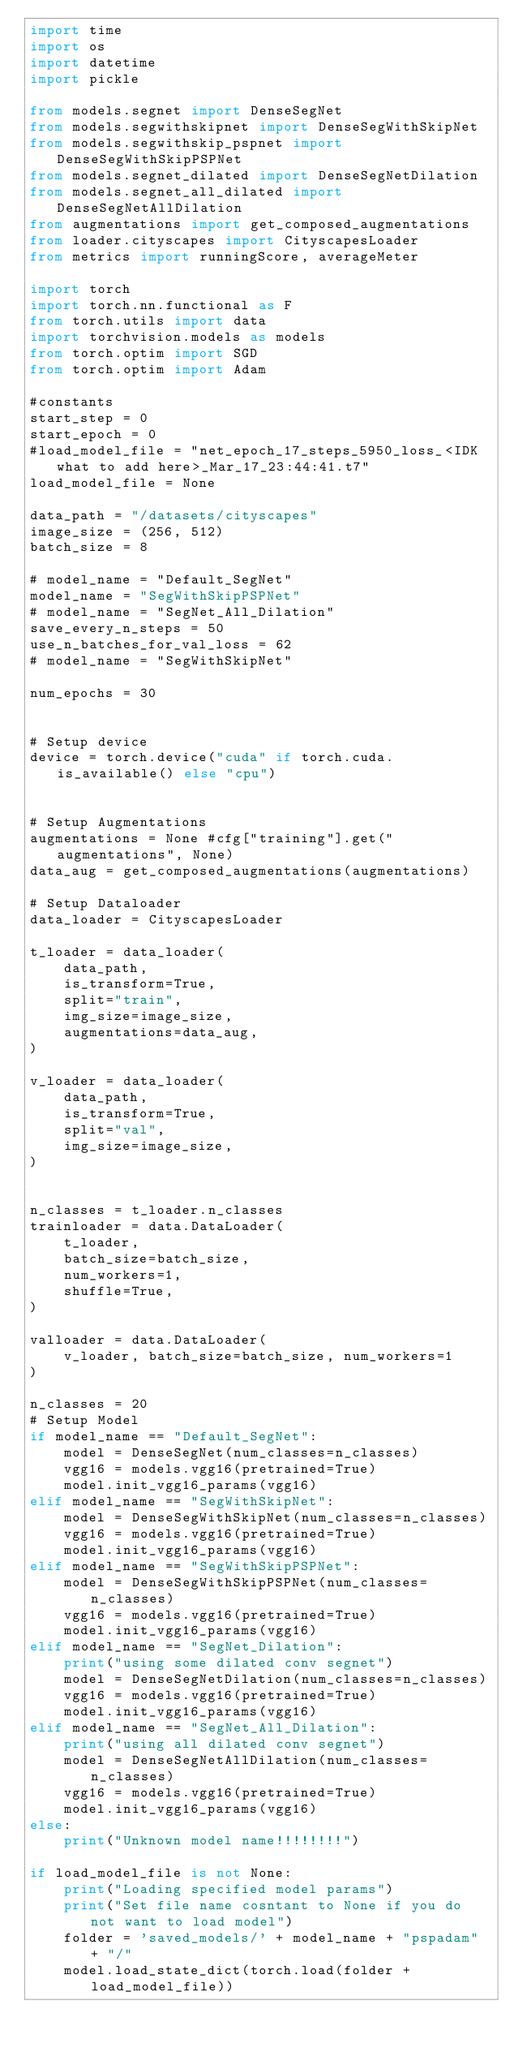Convert code to text. <code><loc_0><loc_0><loc_500><loc_500><_Python_>import time
import os
import datetime
import pickle

from models.segnet import DenseSegNet
from models.segwithskipnet import DenseSegWithSkipNet
from models.segwithskip_pspnet import DenseSegWithSkipPSPNet
from models.segnet_dilated import DenseSegNetDilation
from models.segnet_all_dilated import DenseSegNetAllDilation
from augmentations import get_composed_augmentations
from loader.cityscapes import CityscapesLoader
from metrics import runningScore, averageMeter

import torch
import torch.nn.functional as F
from torch.utils import data
import torchvision.models as models
from torch.optim import SGD
from torch.optim import Adam

#constants
start_step = 0
start_epoch = 0
#load_model_file = "net_epoch_17_steps_5950_loss_<IDK what to add here>_Mar_17_23:44:41.t7"
load_model_file = None

data_path = "/datasets/cityscapes"
image_size = (256, 512)
batch_size = 8

# model_name = "Default_SegNet"
model_name = "SegWithSkipPSPNet"
# model_name = "SegNet_All_Dilation"
save_every_n_steps = 50
use_n_batches_for_val_loss = 62
# model_name = "SegWithSkipNet"

num_epochs = 30


# Setup device
device = torch.device("cuda" if torch.cuda.is_available() else "cpu")


# Setup Augmentations
augmentations = None #cfg["training"].get("augmentations", None)
data_aug = get_composed_augmentations(augmentations)

# Setup Dataloader
data_loader = CityscapesLoader

t_loader = data_loader(
    data_path,
    is_transform=True,
    split="train",
    img_size=image_size,
    augmentations=data_aug,
)

v_loader = data_loader(
    data_path,
    is_transform=True,
    split="val",
    img_size=image_size,
)


n_classes = t_loader.n_classes
trainloader = data.DataLoader(
    t_loader,
    batch_size=batch_size,
    num_workers=1,
    shuffle=True,
)

valloader = data.DataLoader(
    v_loader, batch_size=batch_size, num_workers=1
)

n_classes = 20
# Setup Model
if model_name == "Default_SegNet":
    model = DenseSegNet(num_classes=n_classes)
    vgg16 = models.vgg16(pretrained=True)
    model.init_vgg16_params(vgg16)
elif model_name == "SegWithSkipNet":
    model = DenseSegWithSkipNet(num_classes=n_classes)
    vgg16 = models.vgg16(pretrained=True)
    model.init_vgg16_params(vgg16)    
elif model_name == "SegWithSkipPSPNet":
    model = DenseSegWithSkipPSPNet(num_classes=n_classes)
    vgg16 = models.vgg16(pretrained=True)
    model.init_vgg16_params(vgg16) 
elif model_name == "SegNet_Dilation":
    print("using some dilated conv segnet")
    model = DenseSegNetDilation(num_classes=n_classes)
    vgg16 = models.vgg16(pretrained=True)
    model.init_vgg16_params(vgg16) 
elif model_name == "SegNet_All_Dilation":
    print("using all dilated conv segnet")
    model = DenseSegNetAllDilation(num_classes=n_classes)
    vgg16 = models.vgg16(pretrained=True)
    model.init_vgg16_params(vgg16)
else:
    print("Unknown model name!!!!!!!!")
    
if load_model_file is not None:
    print("Loading specified model params")
    print("Set file name cosntant to None if you do not want to load model")
    folder = 'saved_models/' + model_name + "pspadam" + "/"
    model.load_state_dict(torch.load(folder + load_model_file))
    </code> 